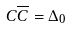Convert formula to latex. <formula><loc_0><loc_0><loc_500><loc_500>C \overline { C } = \Delta _ { 0 }</formula> 